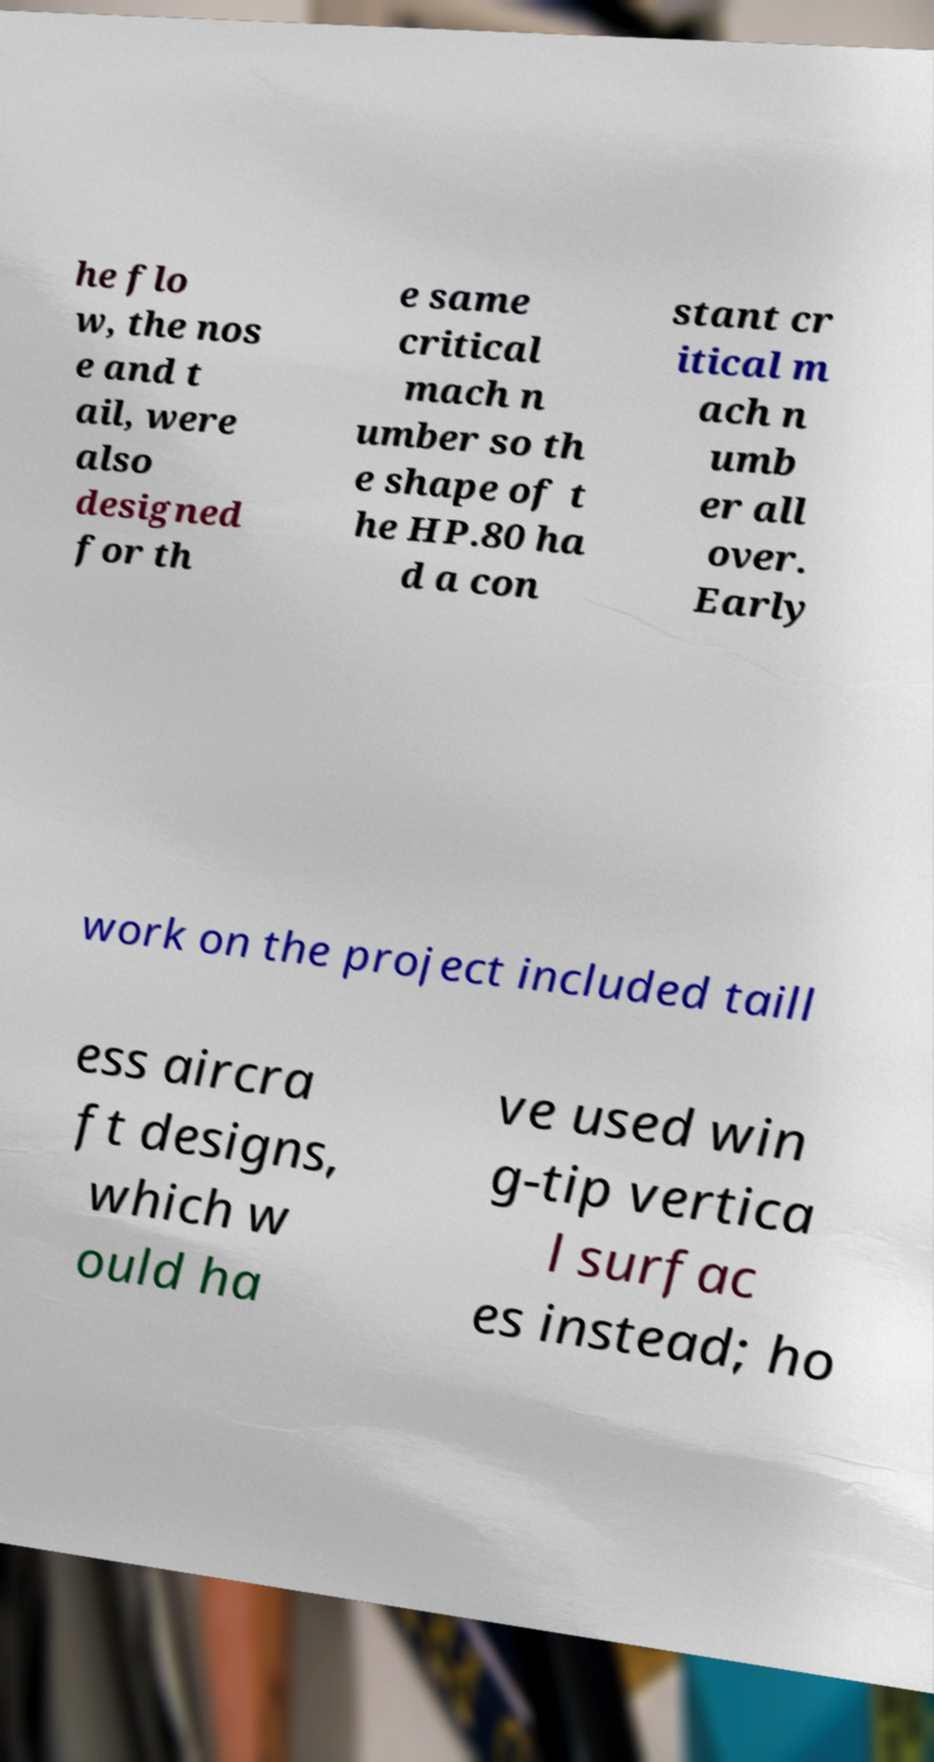Could you assist in decoding the text presented in this image and type it out clearly? he flo w, the nos e and t ail, were also designed for th e same critical mach n umber so th e shape of t he HP.80 ha d a con stant cr itical m ach n umb er all over. Early work on the project included taill ess aircra ft designs, which w ould ha ve used win g-tip vertica l surfac es instead; ho 